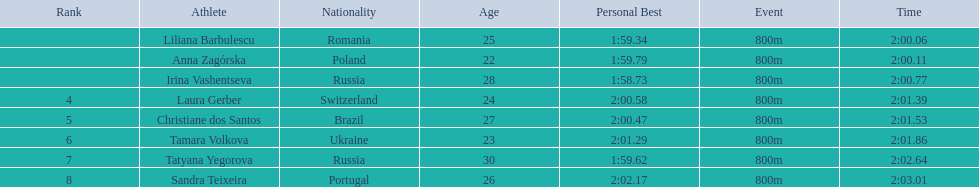What is the number of russian participants in this set of semifinals? 2. 